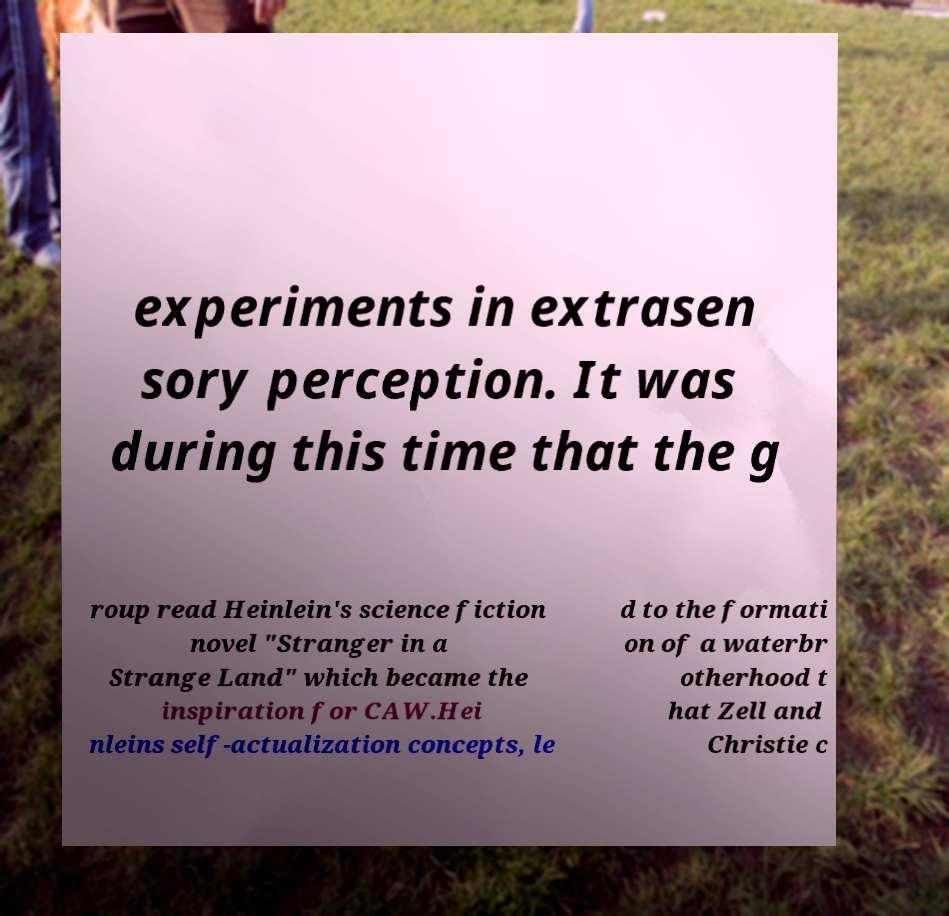Can you accurately transcribe the text from the provided image for me? experiments in extrasen sory perception. It was during this time that the g roup read Heinlein's science fiction novel "Stranger in a Strange Land" which became the inspiration for CAW.Hei nleins self-actualization concepts, le d to the formati on of a waterbr otherhood t hat Zell and Christie c 